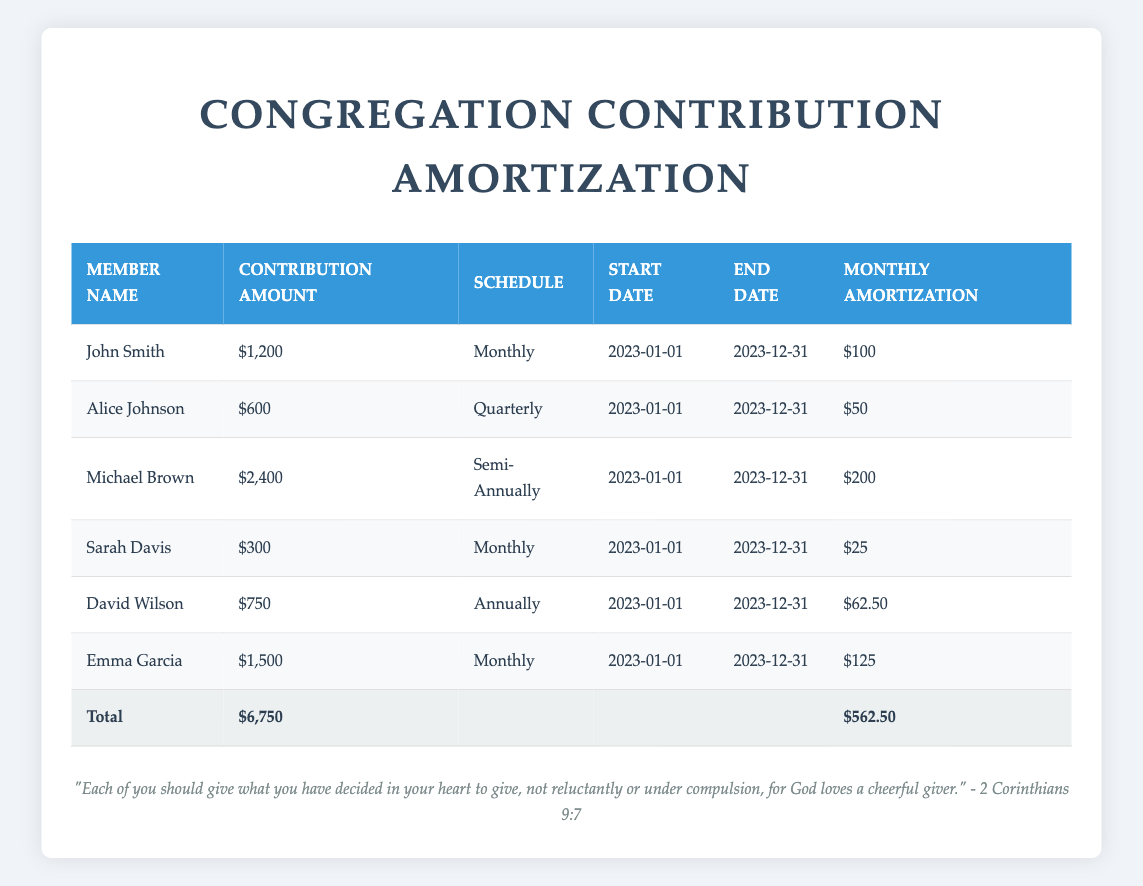What is the total contribution amount from all members? To find the total contribution amount, we simply add the contribution amounts from all members: 1200 + 600 + 2400 + 300 + 750 + 1500 = 6750.
Answer: 6750 How much does Sarah Davis contribute monthly? Sarah Davis's contribution schedule is monthly, and the contribution amount is specified as 300. Since she contributes monthly, the amount remains 300.
Answer: 300 Is Alice Johnson's contribution higher than John Smith's? Alice's contribution is 600, while John's contribution is 1200. Since 600 is less than 1200, the statement is false.
Answer: No What is the total monthly amortization for all members? To calculate the total monthly amortization, we add the monthly amortization amounts from the table: 100 + 50 + 200 + 25 + 62.50 + 125 = 562.50.
Answer: 562.50 Which member contributes the most annually? David Wilson contributes a total of 750 once per year, while others either contribute more frequently or less in total. Thus, David has the highest annual contribution among members who have an annual schedule.
Answer: David Wilson How many members contribute on a monthly basis? From the table, we see that three members (John Smith, Sarah Davis, and Emma Garcia) contribute on a monthly basis.
Answer: 3 What is the average monthly contribution across all members? To find the average monthly contribution, we consider the amortized monthly amounts: 100 + 50 + 200 + 25 + 62.50 + 125 = 562.50 (total monthly) and then divide this by the number of contributing members (6). Thus, 562.50 / 6 = 93.75.
Answer: 93.75 Is Michael Brown's contribution schedule semi-annually? Yes, according to the table, Michael's contribution schedule is noted as semi-annually.
Answer: Yes Which member has the highest total contribution amount, and what is that amount? Michael Brown has the highest total contribution amount at 2400, compared to others.
Answer: Michael Brown, 2400 